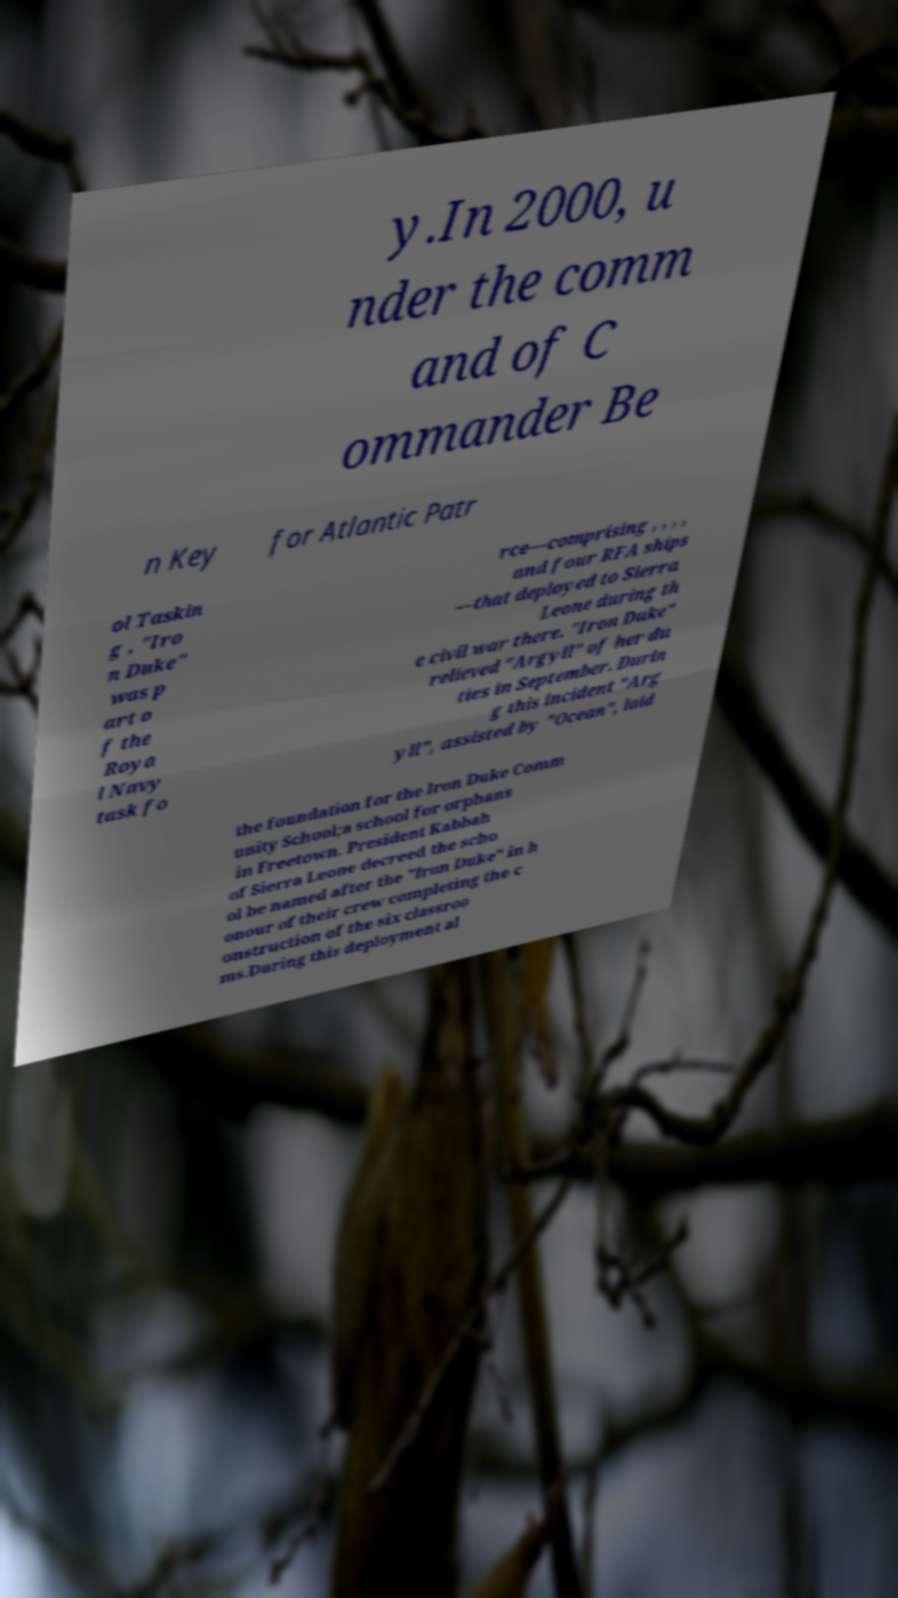For documentation purposes, I need the text within this image transcribed. Could you provide that? y.In 2000, u nder the comm and of C ommander Be n Key for Atlantic Patr ol Taskin g , "Iro n Duke" was p art o f the Roya l Navy task fo rce—comprising , , , , and four RFA ships —that deployed to Sierra Leone during th e civil war there. "Iron Duke" relieved "Argyll" of her du ties in September. Durin g this incident "Arg yll", assisted by "Ocean", laid the foundation for the Iron Duke Comm unity School;a school for orphans in Freetown. President Kabbah of Sierra Leone decreed the scho ol be named after the "Iron Duke" in h onour of their crew completing the c onstruction of the six classroo ms.During this deployment al 